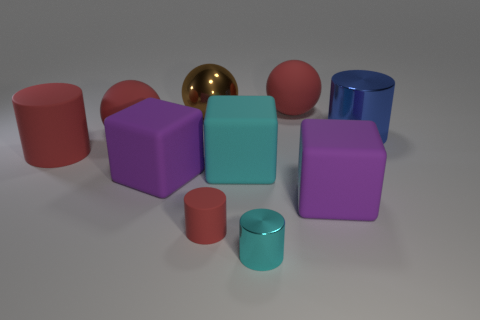Subtract 1 cylinders. How many cylinders are left? 3 Subtract all brown cylinders. Subtract all red cubes. How many cylinders are left? 4 Subtract all cubes. How many objects are left? 7 Add 8 large brown things. How many large brown things are left? 9 Add 7 big cyan matte blocks. How many big cyan matte blocks exist? 8 Subtract 0 purple balls. How many objects are left? 10 Subtract all small shiny blocks. Subtract all small cylinders. How many objects are left? 8 